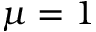Convert formula to latex. <formula><loc_0><loc_0><loc_500><loc_500>\mu = 1</formula> 